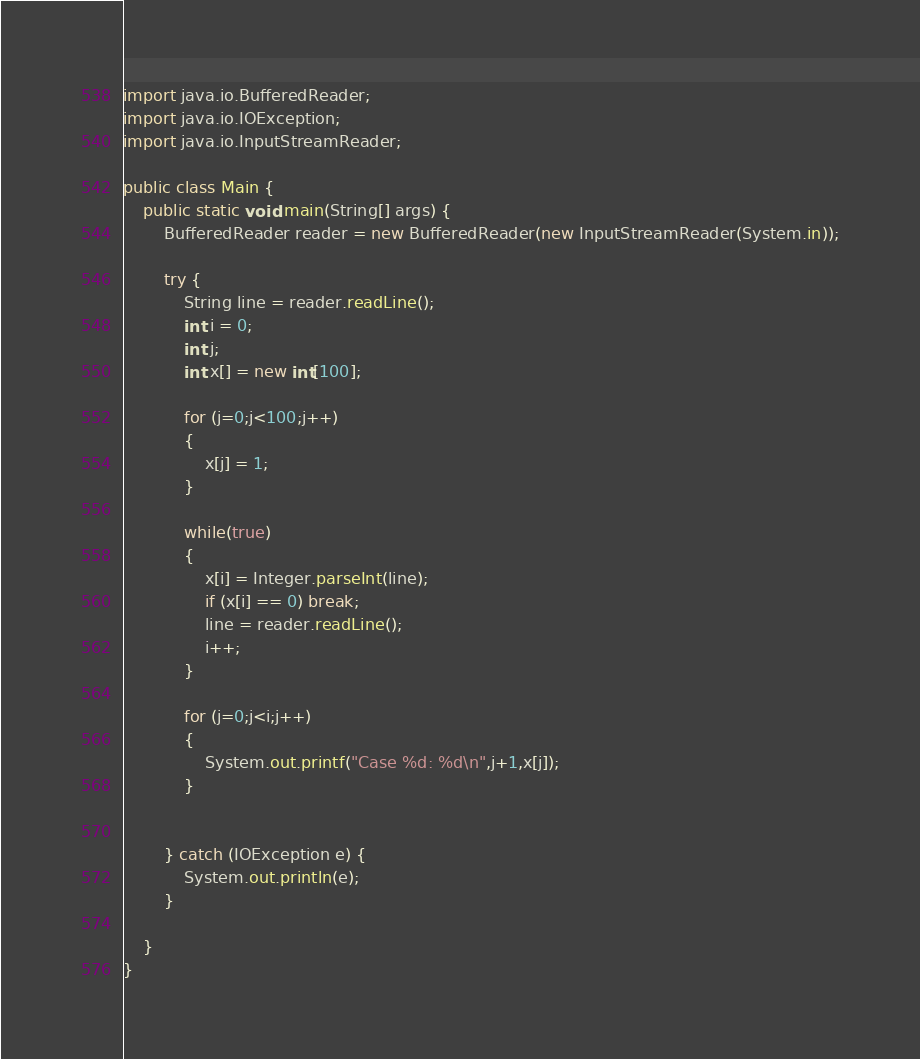<code> <loc_0><loc_0><loc_500><loc_500><_Java_>import java.io.BufferedReader;
import java.io.IOException;
import java.io.InputStreamReader;

public class Main {
	public static void main(String[] args) {
		BufferedReader reader = new BufferedReader(new InputStreamReader(System.in));

		try {
			String line = reader.readLine();
			int i = 0;
			int j;
			int x[] = new int[100];
			
			for (j=0;j<100;j++)
			{
				x[j] = 1;
			}

			while(true)
			{
				x[i] = Integer.parseInt(line);
				if (x[i] == 0) break;
				line = reader.readLine();
				i++;
			}

			for (j=0;j<i;j++)
			{
				System.out.printf("Case %d: %d\n",j+1,x[j]);
			}
		

		} catch (IOException e) {
			System.out.println(e);
		}

	}
}</code> 